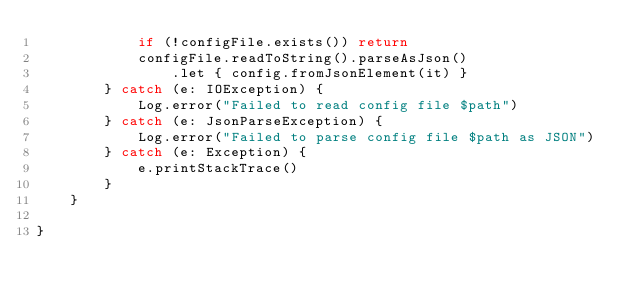<code> <loc_0><loc_0><loc_500><loc_500><_Kotlin_>            if (!configFile.exists()) return
            configFile.readToString().parseAsJson()
                .let { config.fromJsonElement(it) }
        } catch (e: IOException) {
            Log.error("Failed to read config file $path")
        } catch (e: JsonParseException) {
            Log.error("Failed to parse config file $path as JSON")
        } catch (e: Exception) {
            e.printStackTrace()
        }
    }

}</code> 